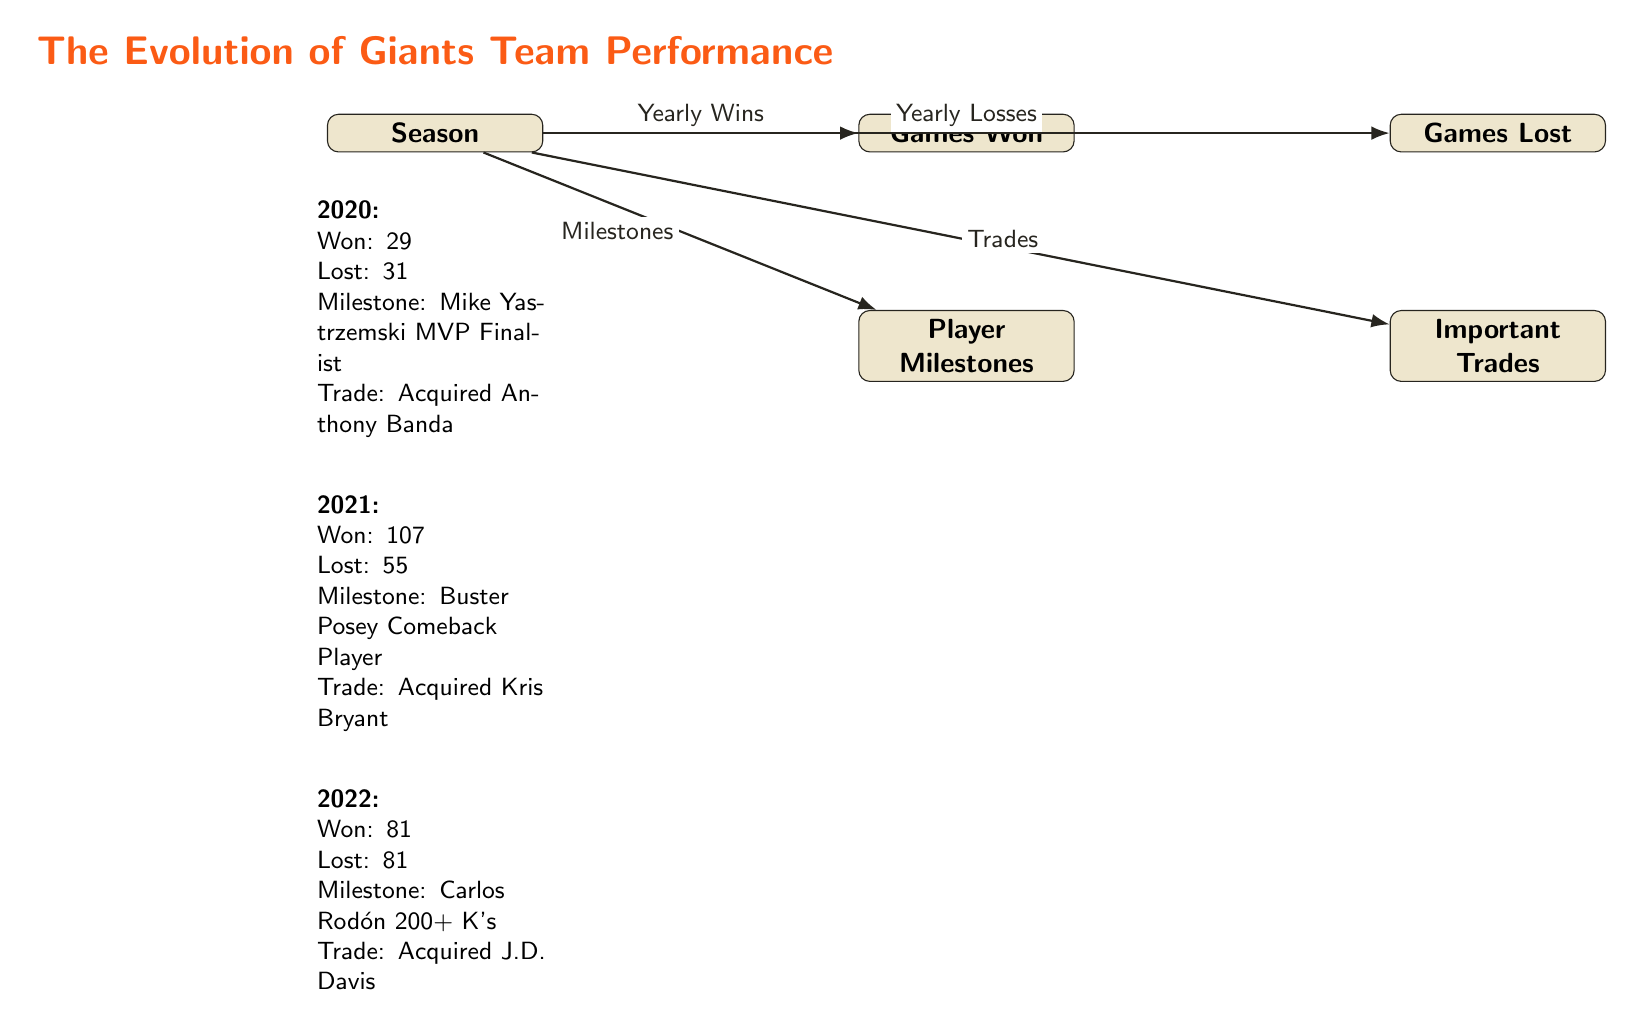What is the total number of seasons represented in the diagram? The diagram shows data for three seasons: 2020, 2021, and 2022. We identify each labeled year in the data section to determine the count.
Answer: 3 Which year did the Giants have the highest number of games won? By examining the wins listed for each year, 2021 has the highest value with 107 wins. This is confirmed by reading the relevant node and comparing against others.
Answer: 2021 What is the total number of losses for the year 2022? The diagram explicitly states that the Giants lost 81 games in the year 2022, as noted in that year's data. There is no need for further calculations.
Answer: 81 Which player was a Comeback Player in 2021? The diagram states that Buster Posey was the Comeback Player in the year 2021, which can be found in the milestones for that season. Review that section for the specific player's name.
Answer: Buster Posey What was a significant trade made in 2020? The diagram indicates that the Giants acquired Anthony Banda in 2020, and this information is located in that year’s trade section of the data presented.
Answer: Acquired Anthony Banda How many games did the Giants win in 2020? The diagram shows that the Giants won 29 games in 2020. By looking at the corresponding data node for that season, we can find the exact number.
Answer: 29 Which year did the Giants experience a 50% win-loss record? Observing the wins and losses in 2022, where they won 81 and lost 81 games, we can conclude that this year represents a 50% win-loss record.
Answer: 2022 What milestone did Carlos Rodón achieve in 2022? The diagram notes that Carlos Rodón achieved 200+ K's in 2022 as a player milestone, which can be found in that particular data section of the diagram.
Answer: 200+ K's In which year did the Giants implement a significant trade by acquiring Kris Bryant? According to the diagram, Kris Bryant was acquired in 2021, and this information can be quickly located under the trades section for that year.
Answer: 2021 